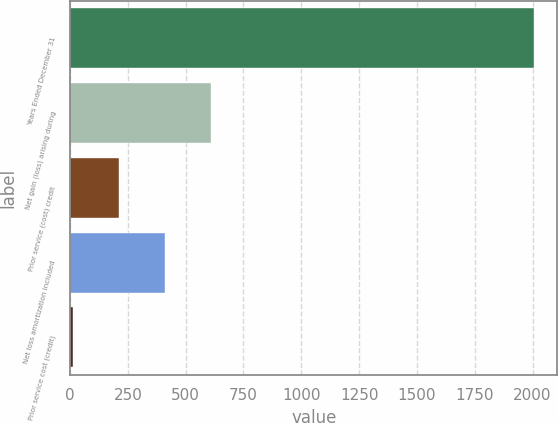Convert chart. <chart><loc_0><loc_0><loc_500><loc_500><bar_chart><fcel>Years Ended December 31<fcel>Net gain (loss) arising during<fcel>Prior service (cost) credit<fcel>Net loss amortization included<fcel>Prior service cost (credit)<nl><fcel>2007<fcel>610.57<fcel>211.59<fcel>411.08<fcel>12.1<nl></chart> 